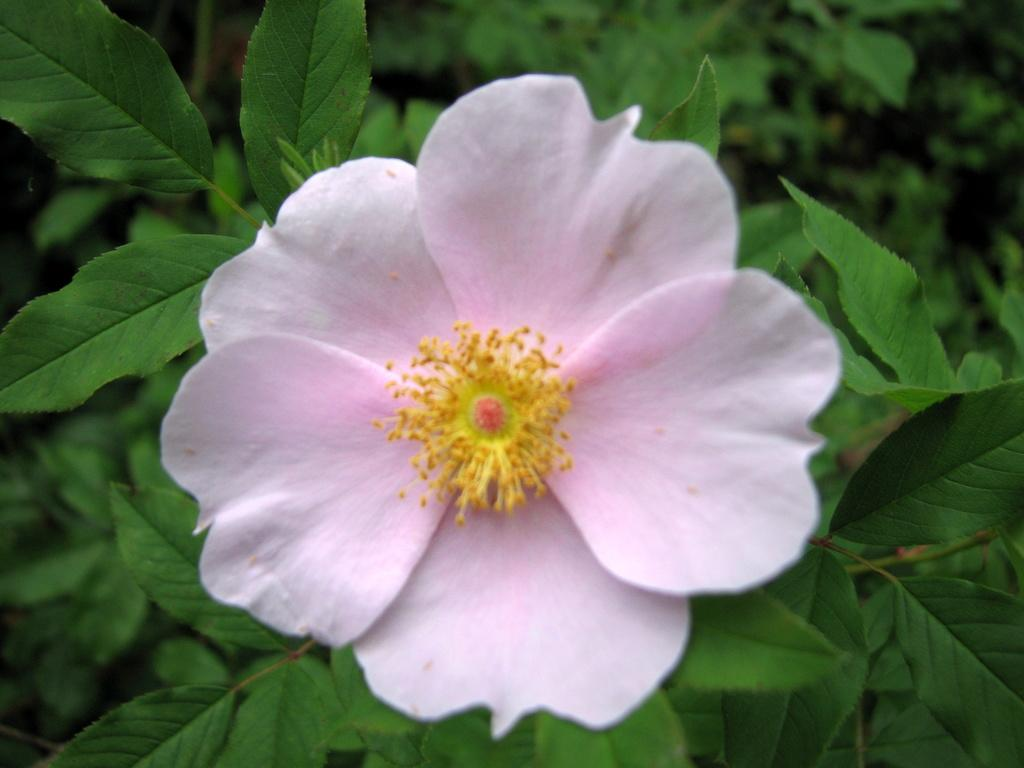What type of plant is visible in the image? There is a flower on a plant in the image. Are there any other plants present in the image? Yes, there are other plants in the image. What type of corn can be seen growing on the stick in the image? There is no corn or stick present in the image; it features a flower on a plant and other plants. 